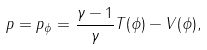Convert formula to latex. <formula><loc_0><loc_0><loc_500><loc_500>p = p _ { \phi } = \frac { \gamma - 1 } { \gamma } T ( \phi ) - V ( \phi ) ,</formula> 